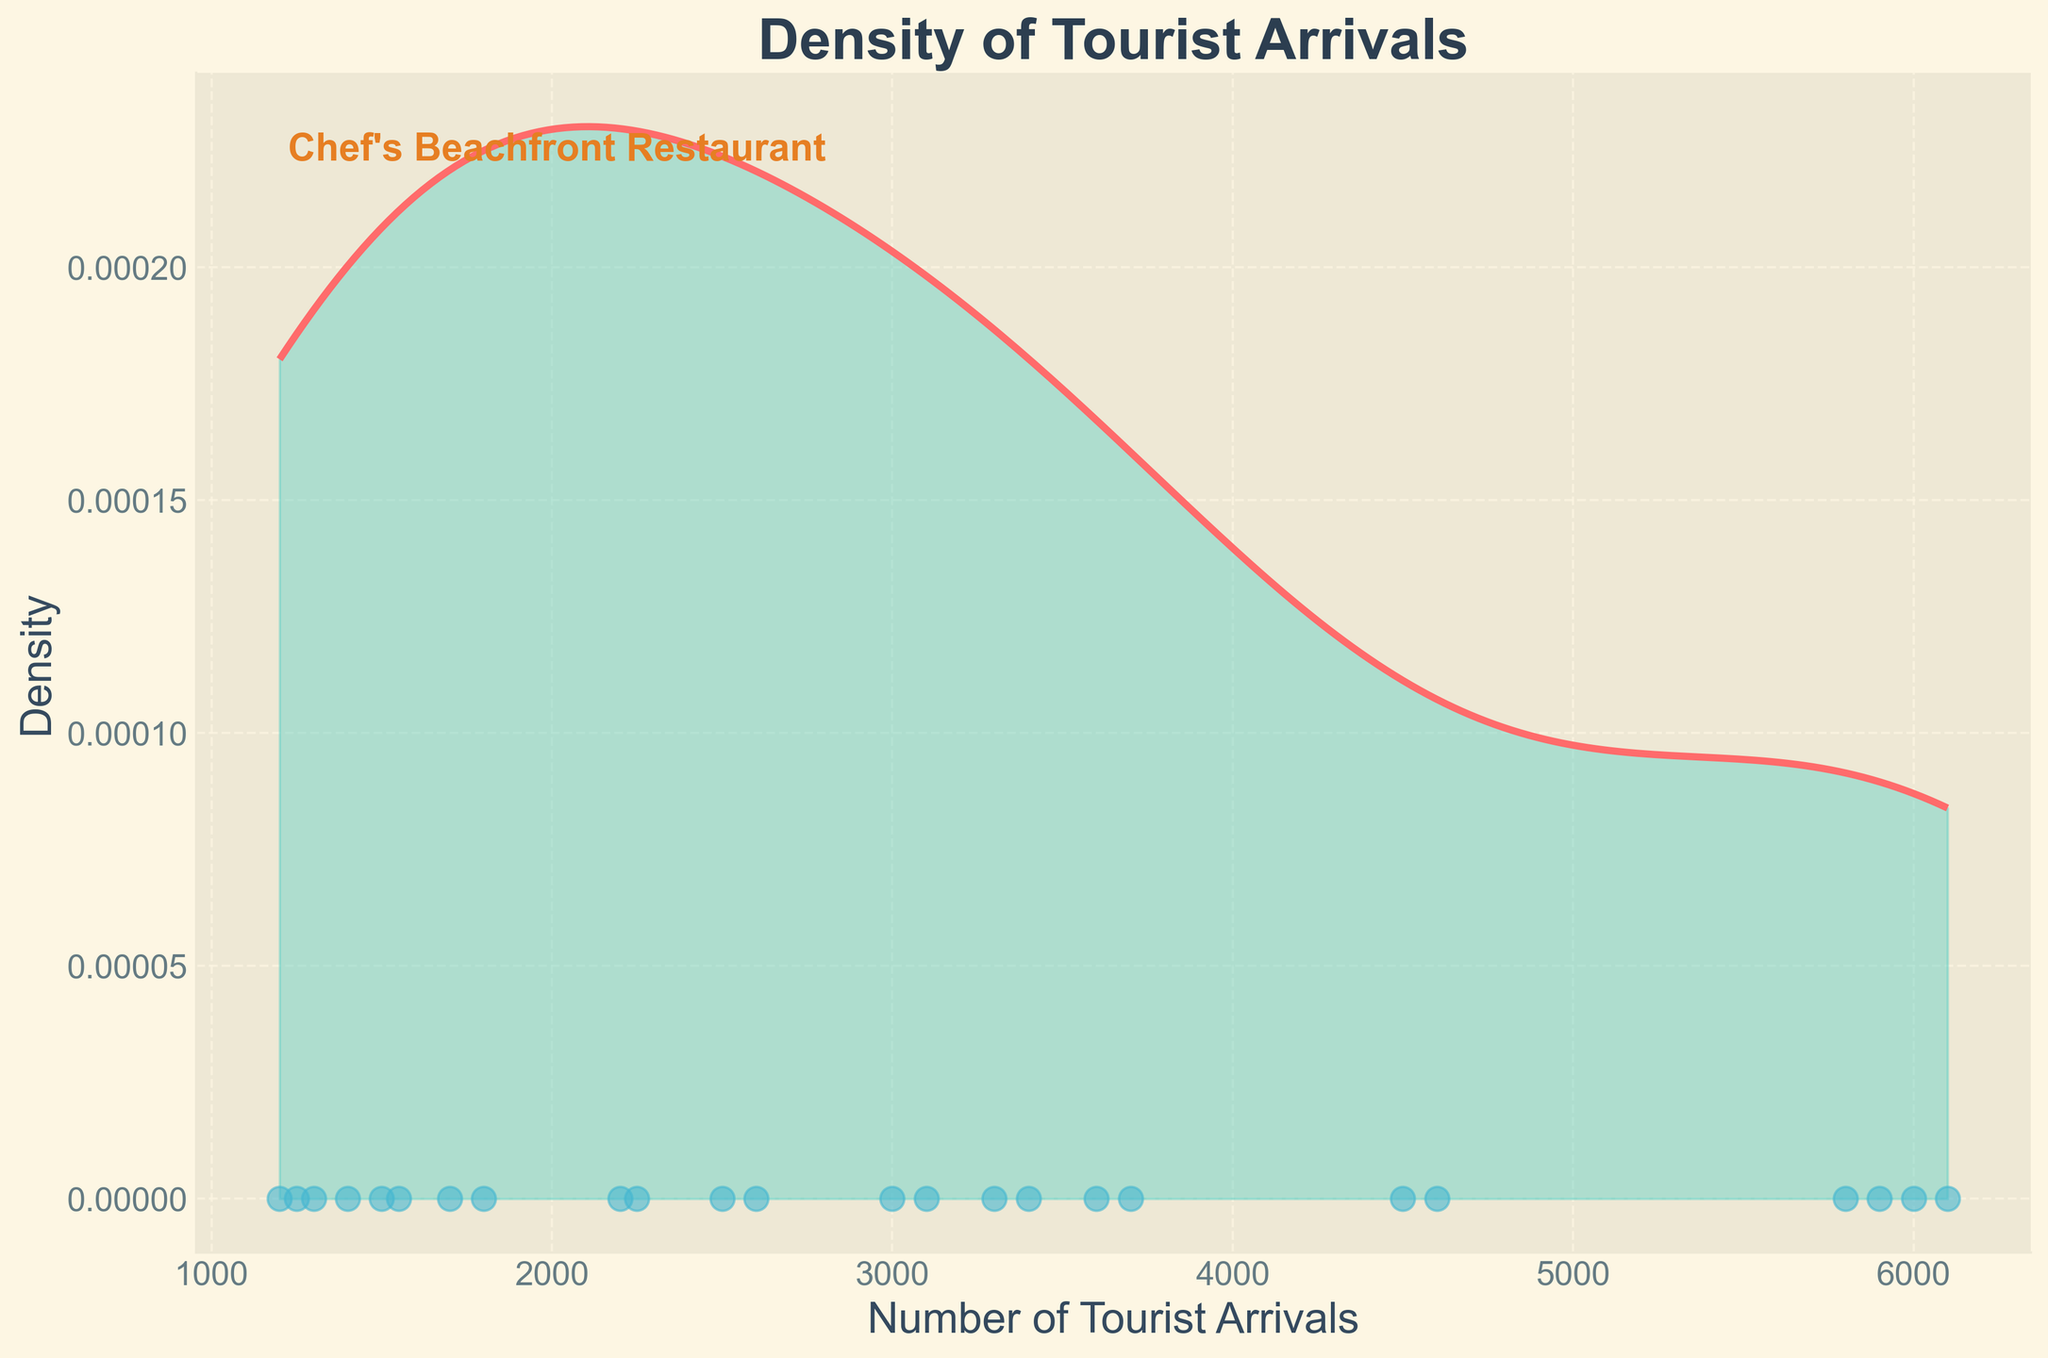what is the title of the plot? The title of a plot is usually located at the top. Here, it reads "Density of Tourist Arrivals".
Answer: Density of Tourist Arrivals what is the color of the density curve? The color of the density curve can be observed from the plot. It is a distinctive bright color, which is red.
Answer: red how many months of tourist arrival data are displayed as scatter points? Each scatter point represents a monthly data point. We need to count the number of scatter points along the x-axis. There are 24 months worth of data, representing two years.
Answer: 24 what is the range of the x-axis showing the number of tourist arrivals? The range of the x-axis, representing tourist arrivals, extends from the minimum to the maximum values in the dataset. The plot shows a range from about 1200 to 6100.
Answer: 1200 to 6100 how can you tell the months with the highest density of tourist arrivals? The density plot has peaks where data clusters around certain values. The higher the peak, the denser the data points around that value. The tallest peak is found around the tourist arrivals of June to August, indicating the highest density.
Answer: June to August which range of tourist arrivals has the highest density and what does this indicate? Observing the highest peak in the density curve will show the highest density. This occurs around 4500 to 6100 tourist arrivals, indicating the months with these arrival numbers (June to July) have the highest tourist density.
Answer: 4500 to 6100 do the tourist arrivals in winter months have higher or lower density compared to summer months? Comparing the density across the x-axis, we see that the density in summer months (June to August) is higher, with more pronounced peaks, while the density in winter months (December to February) is much lower with flatter curves.
Answer: lower which month shows the lowest tourist arrivals based on scatter points? The scatter points along the x-axis represent monthly tourist arrivals. The lowest point is around 1200, which corresponds to January 2022.
Answer: January 2022 is the density of tourist arrivals more concentrated in any specific months? The density plot shows concentration through peaks. The plot has clear peaks around June to August, indicating higher concentration in these months compared to other months which have flatter, lower peaks.
Answer: Yes, June to August is the number of tourist arrivals in November higher in 2023 than in 2022? We need to compare scatter points from November 2022 and November 2023. The plot shows that the scatter point for November 2023 is slightly higher.
Answer: Yes 